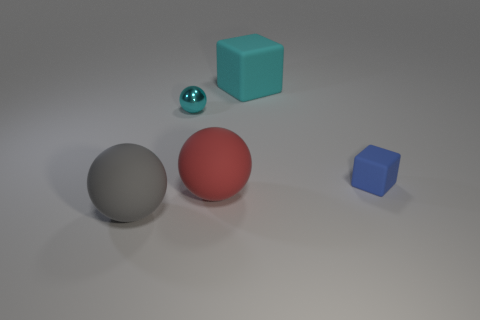Are there any big gray matte spheres behind the large cyan matte block?
Your answer should be compact. No. The cube behind the blue rubber block to the right of the cyan matte cube is made of what material?
Your answer should be compact. Rubber. There is a cyan object that is the same shape as the red thing; what is its size?
Provide a short and direct response. Small. Is the metal ball the same color as the big cube?
Provide a short and direct response. Yes. There is a big thing that is both on the right side of the cyan shiny ball and in front of the small shiny object; what color is it?
Your response must be concise. Red. Do the matte sphere behind the gray sphere and the big gray thing have the same size?
Provide a short and direct response. Yes. Is there any other thing that is the same shape as the large red rubber thing?
Give a very brief answer. Yes. Do the small blue block and the large sphere that is to the right of the gray matte sphere have the same material?
Provide a succinct answer. Yes. How many green things are either big matte balls or metal balls?
Ensure brevity in your answer.  0. Are there any green metal blocks?
Provide a short and direct response. No. 